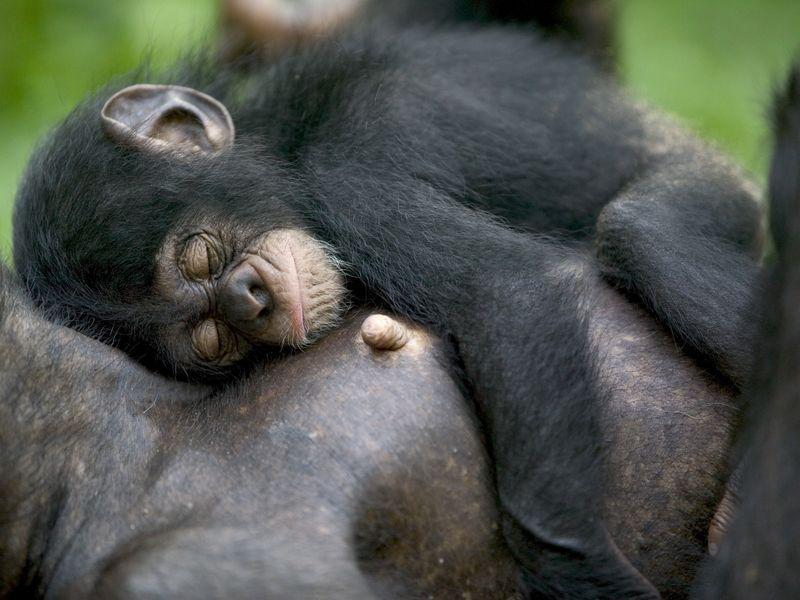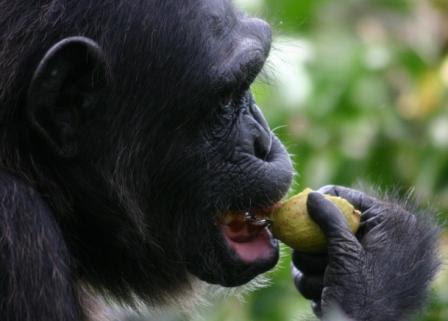The first image is the image on the left, the second image is the image on the right. Given the left and right images, does the statement "An image shows a baby chimp sleeping on top of an adult chimp." hold true? Answer yes or no. Yes. The first image is the image on the left, the second image is the image on the right. Evaluate the accuracy of this statement regarding the images: "One animal is sleeping on another in the image on the left.". Is it true? Answer yes or no. Yes. 